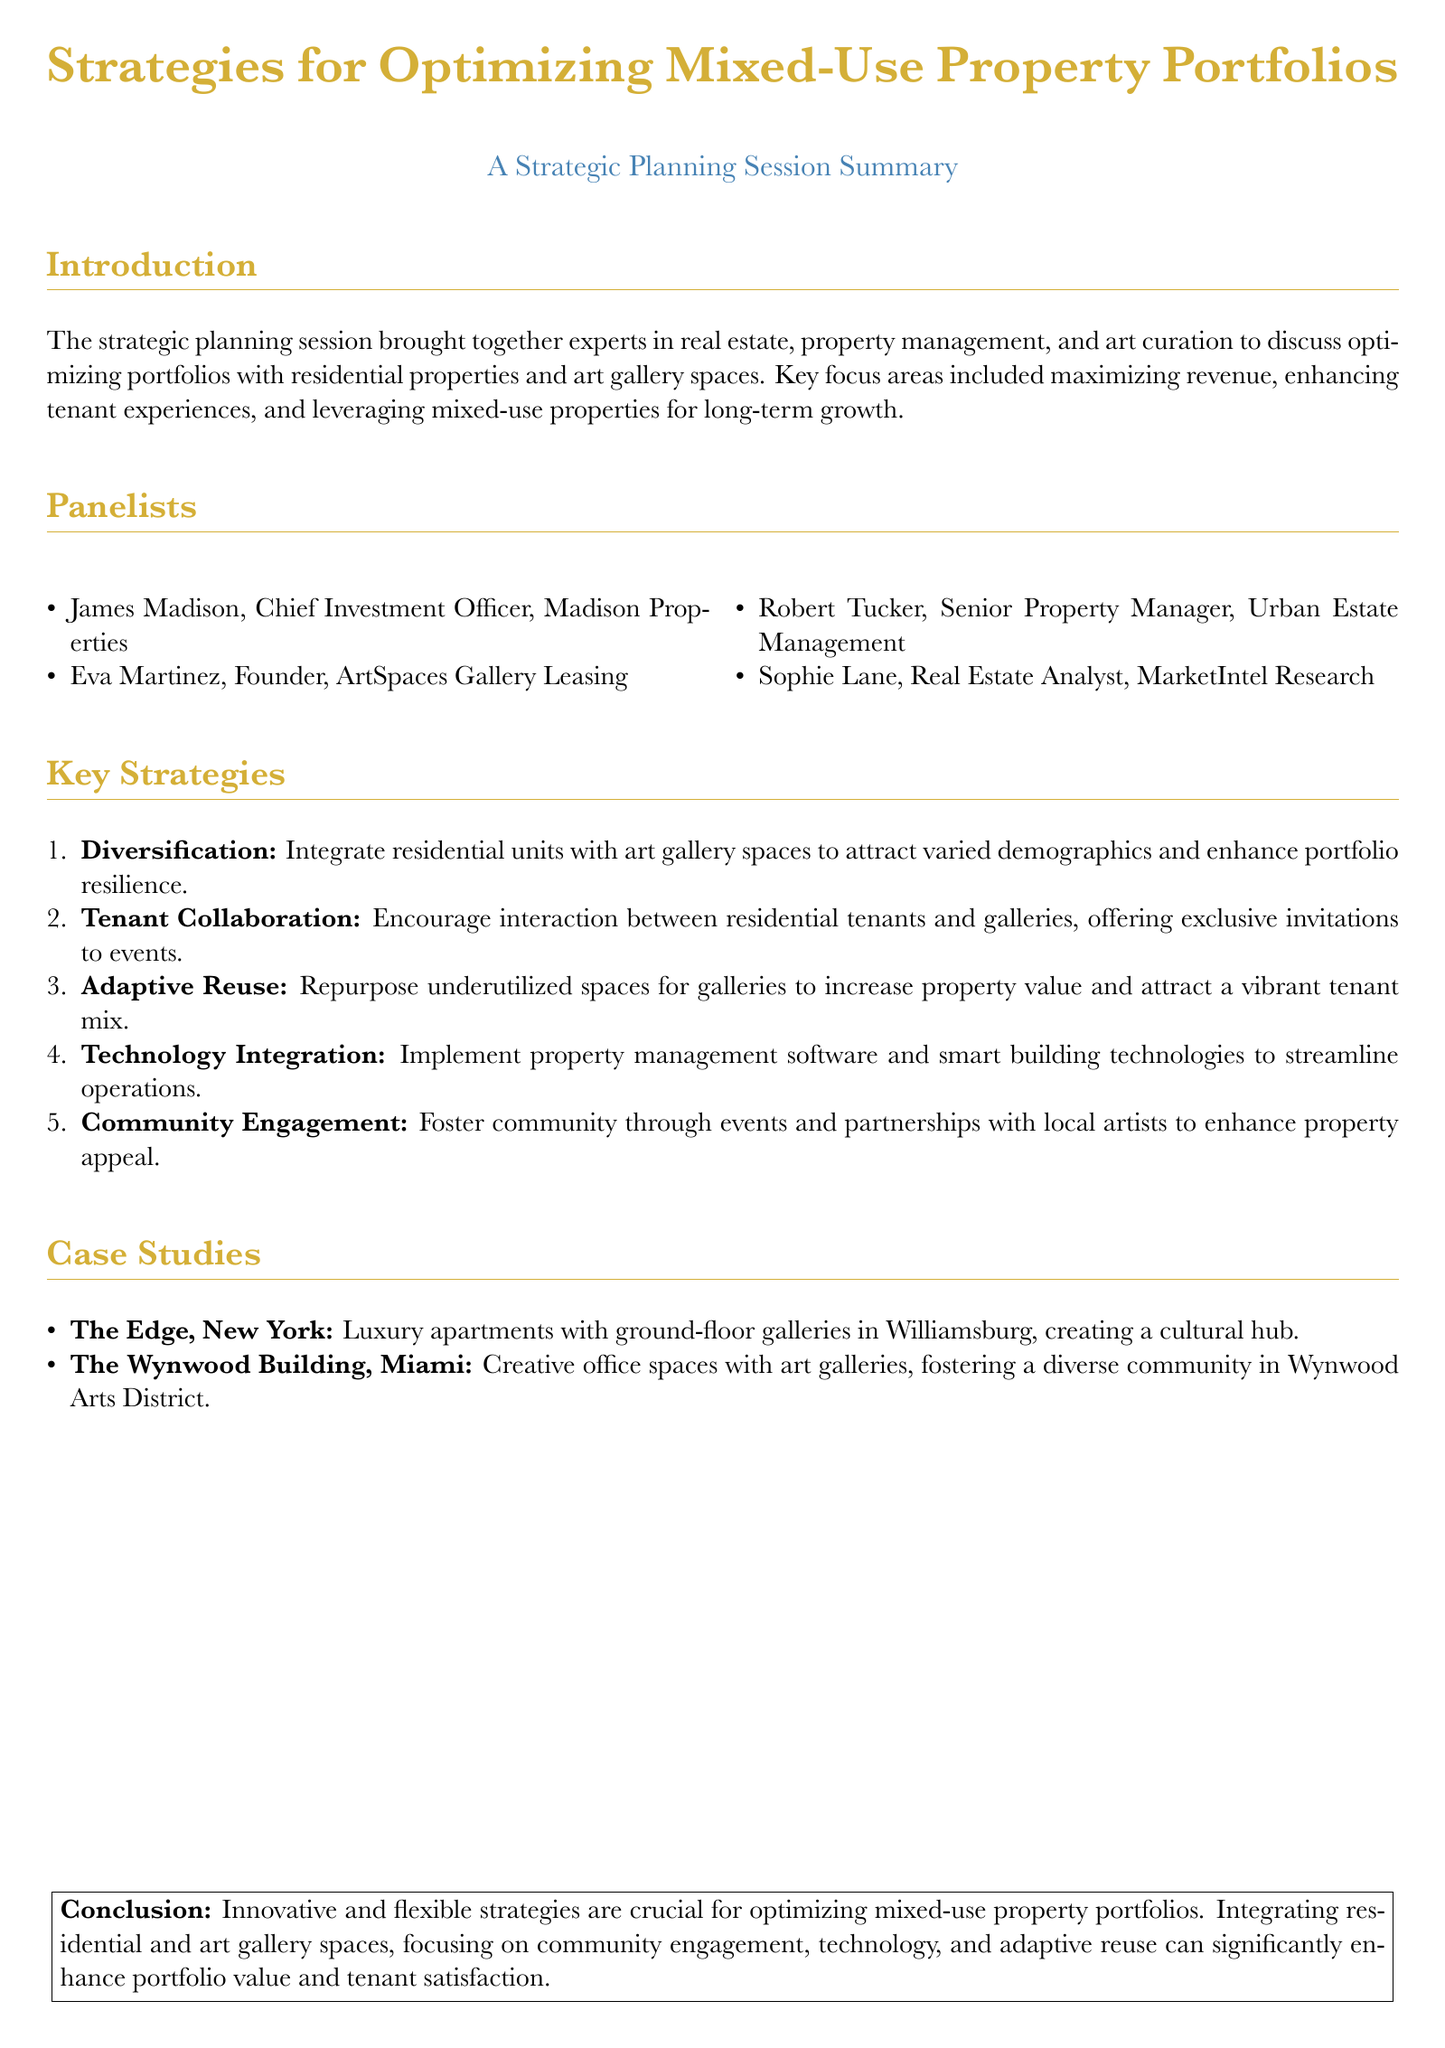What was the main focus of the strategic planning session? The main focus was on optimizing portfolios with residential properties and art gallery spaces.
Answer: Optimizing portfolios Who is the Chief Investment Officer mentioned in the document? The Chief Investment Officer mentioned is James Madison.
Answer: James Madison What is one of the key strategies for optimizing mixed-use properties? One key strategy is to integrate residential units with art gallery spaces.
Answer: Integrate residential units with art gallery spaces Which property is an example of luxury apartments with ground-floor galleries? The example given is The Edge in New York.
Answer: The Edge What does the document suggest to enhance tenant experiences? The document suggests encouraging interaction between residential tenants and galleries.
Answer: Encourage interaction between residential tenants and galleries What technology is recommended for streamlining operations? Property management software and smart building technologies are recommended.
Answer: Property management software and smart building technologies What type of community activities does the document promote? The document promotes community engagement through events and partnerships with local artists.
Answer: Community engagement How many panelists are listed in the document? There are four panelists listed in the document.
Answer: Four What concept involves repurposing underutilized spaces? The concept referred to is adaptive reuse.
Answer: Adaptive reuse 